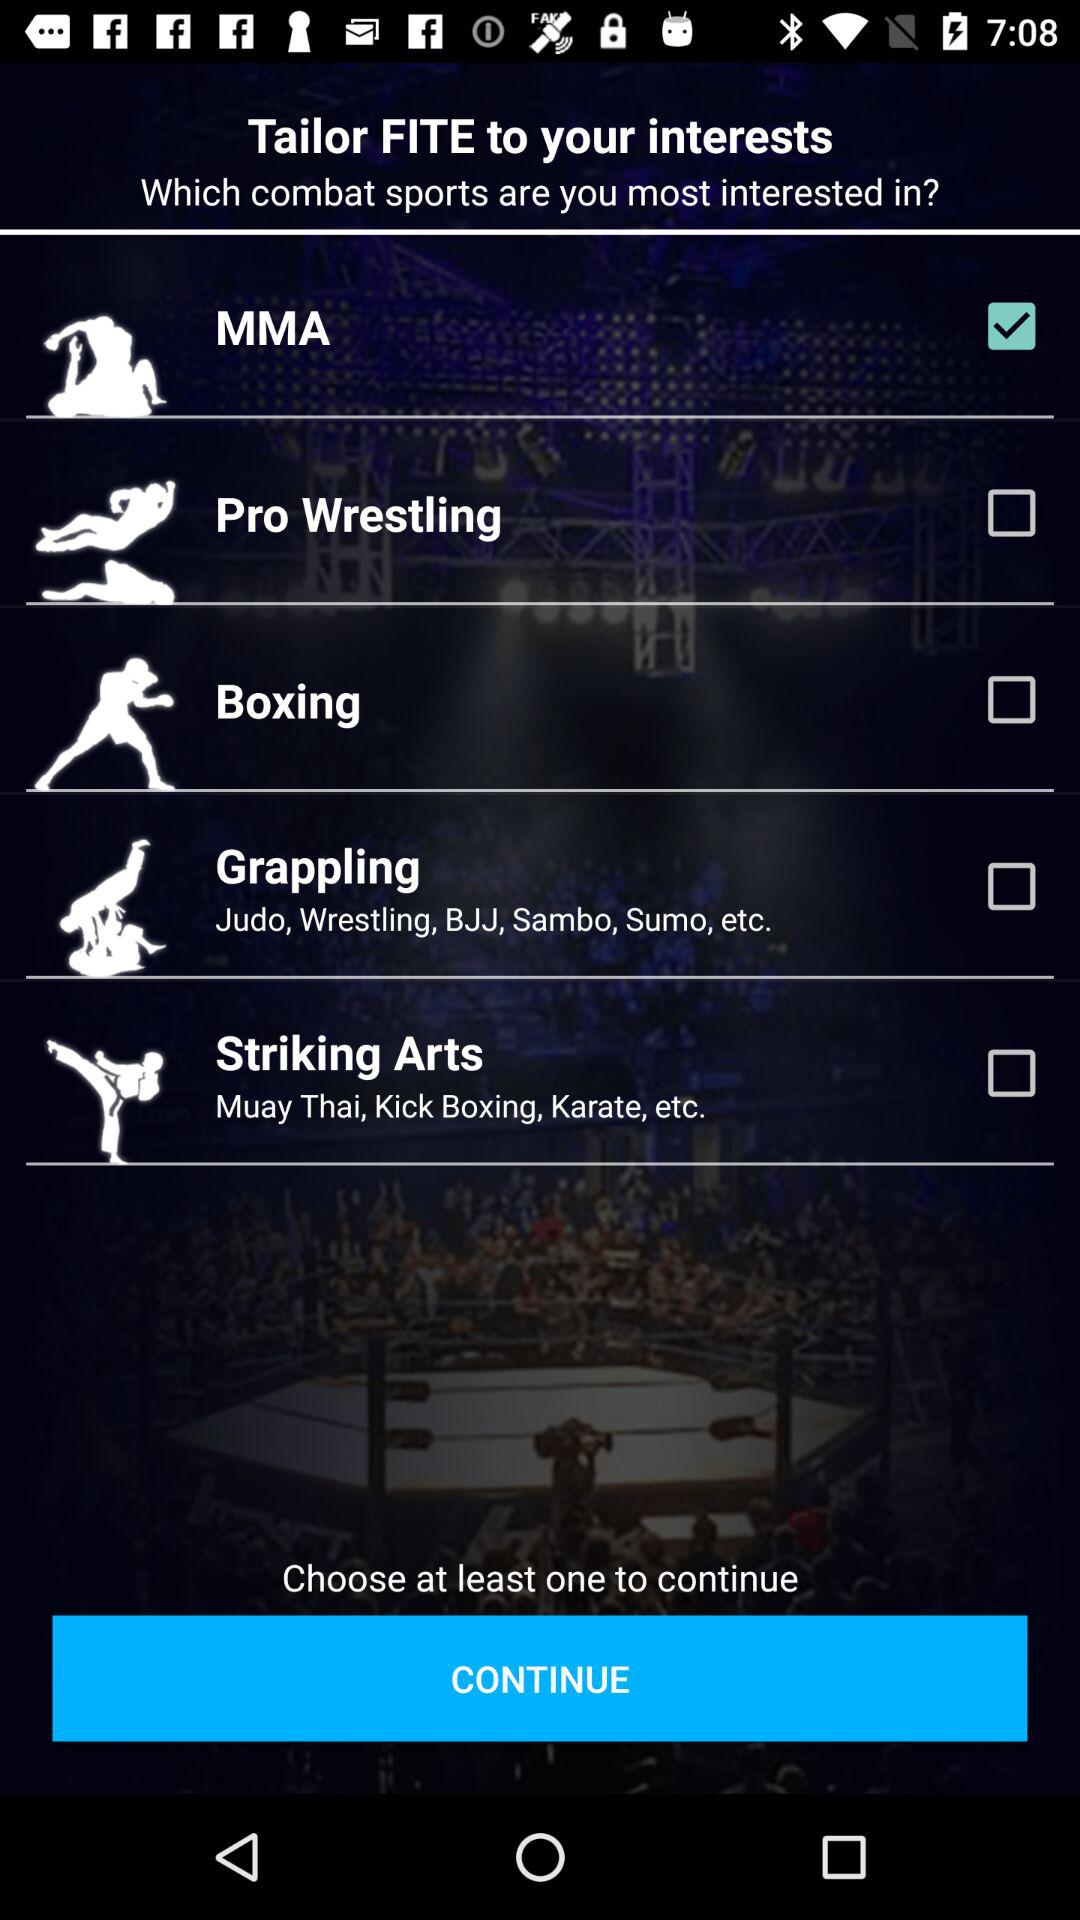Which option is unchecked? The unchecked options are "Pro Wrestling", "Boxing", "Grappling" and "Striking Arts". 